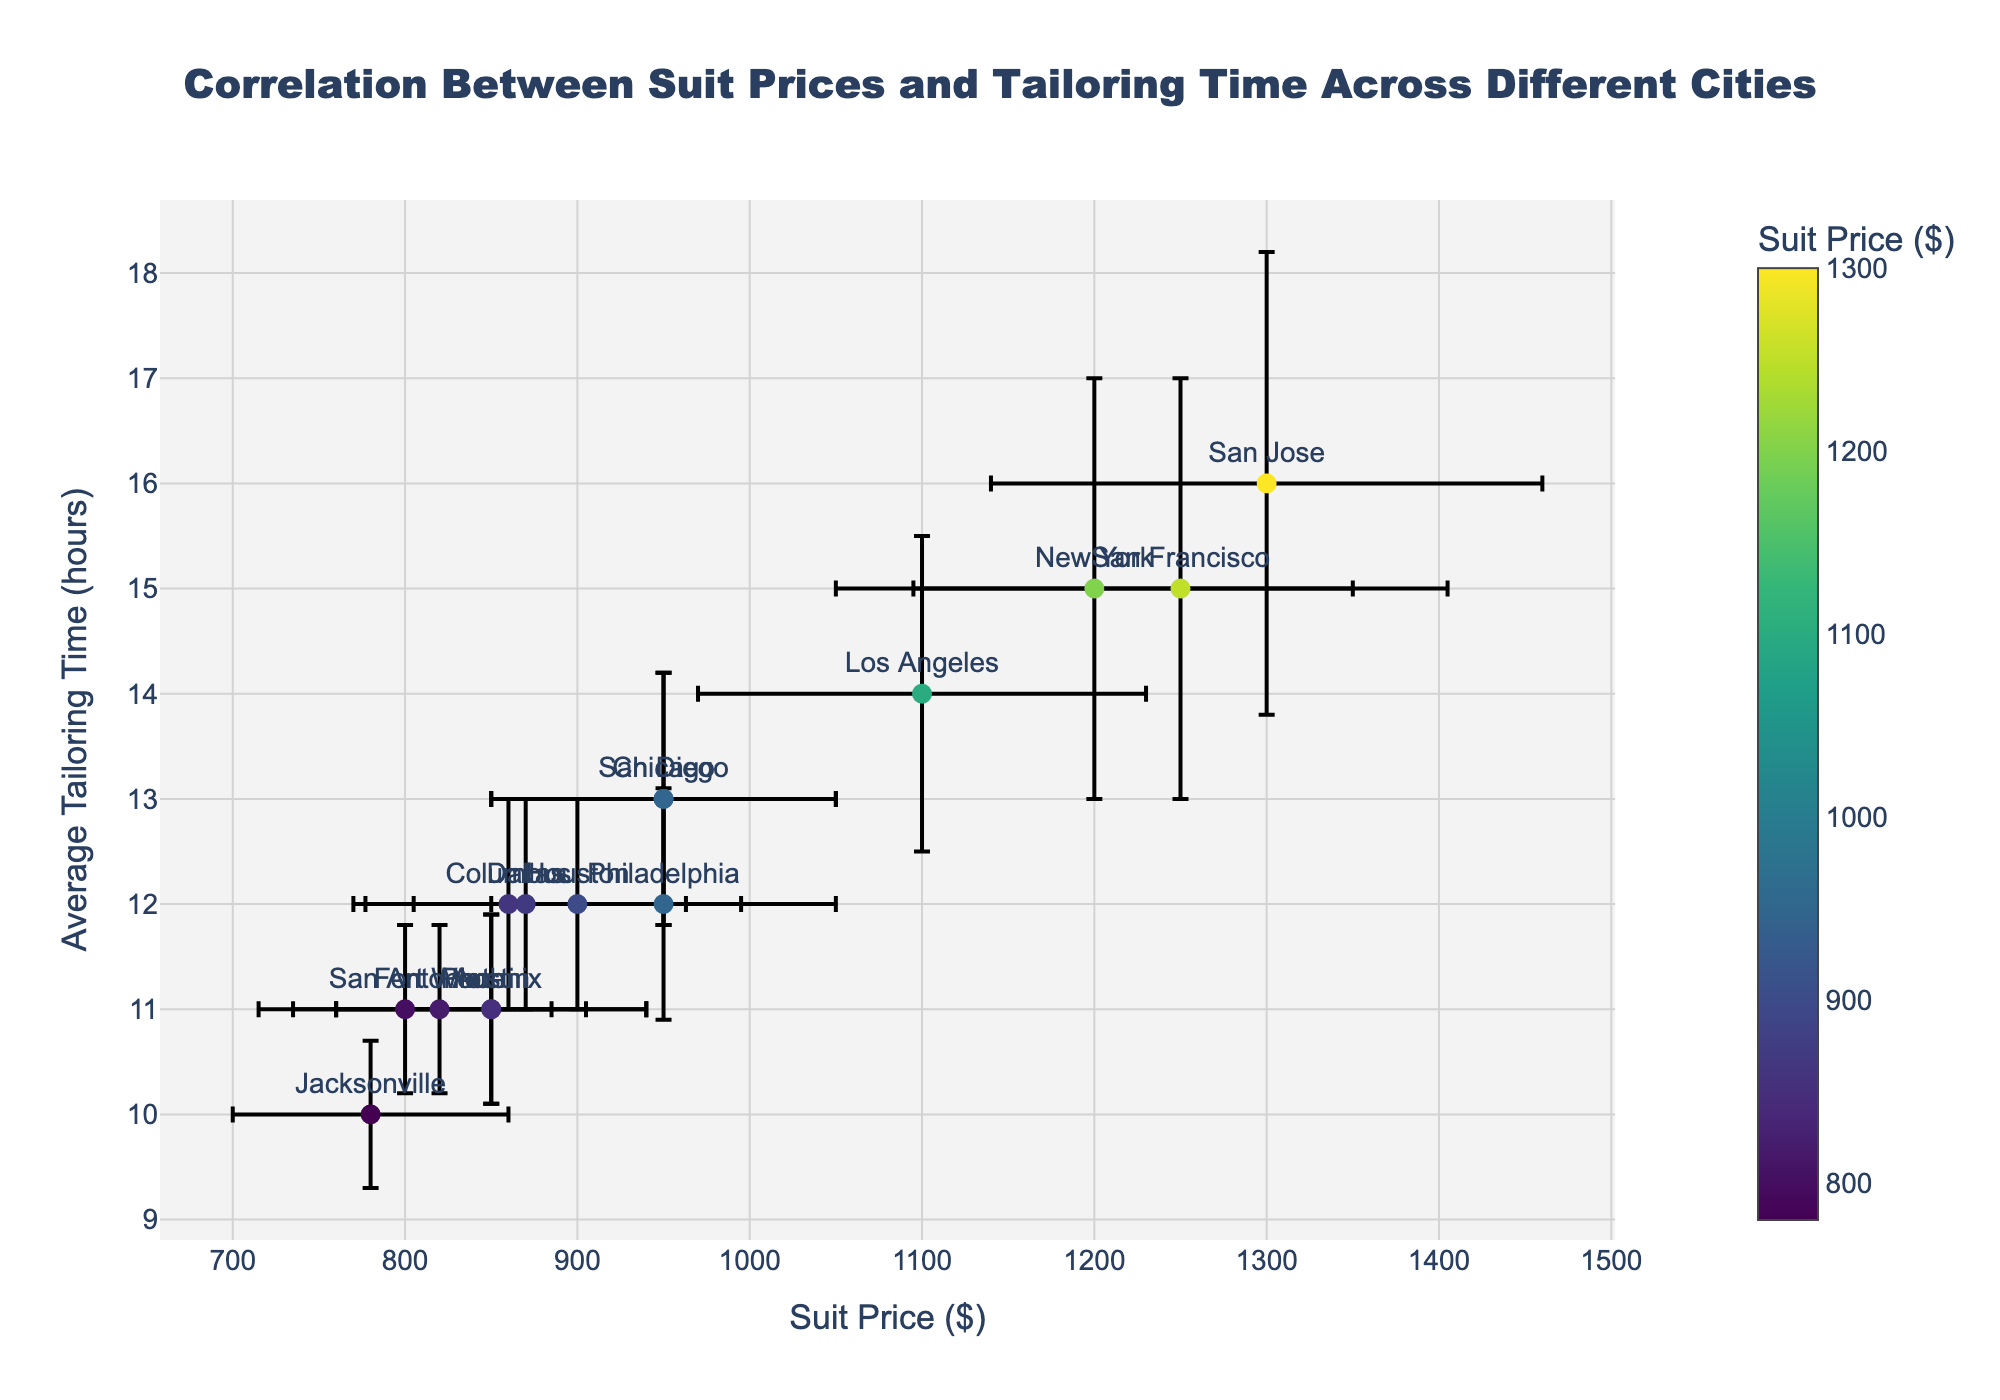What is the title of the plot? The title is located at the top center of the plot, it reads "Correlation Between Suit Prices and Tailoring Time Across Different Cities".
Answer: Correlation Between Suit Prices and Tailoring Time Across Different Cities What are the ranges of suit prices and average tailoring times displayed in the plot? The x-axis (suit prices) ranges from about $780 to $1300, and the y-axis (average tailoring times) ranges from about 10 to 16 hours.
Answer: $780 to $1300, 10 to 16 hours Which city has the highest suit price and what is its average tailoring time? The scatter point corresponding to San Jose has the highest suit price at $1300, with an average tailoring time of 16 hours.
Answer: San Jose, 16 hours What is the city with the lowest average tailoring time and its suit price? Jacksonville has the lowest average tailoring time of 10 hours, and its suit price is $780.
Answer: Jacksonville, $780 How many cities have an average tailoring time of 15 hours? Looking at the y-axis and the scatter points, two cities (New York and San Francisco) have an average tailoring time of 15 hours.
Answer: 2 Which city has a higher average tailoring time: Los Angeles or Chicago? From the plot, Los Angeles has an average tailoring time of 14 hours, while Chicago has 13 hours, so Los Angeles has a higher average tailoring time.
Answer: Los Angeles How do the error bars for suit price and tailoring time compare for New York and San Francisco? Both New York and San Francisco have similar length error bars for suit price (New York: $150, San Francisco: $155) and average tailoring time (both 2 hours), indicating comparable uncertainty in these measurements.
Answer: Comparable What is the average suit price among cities with an average tailoring time of 11 hours? The cities with an average tailoring time of 11 hours are Phoenix, San Antonio, Austin, and Fort Worth. Their suit prices are $850, $800, $850, and $820 respectively. The average suit price is calculated as ($850 + $800 + $850 + $820) / 4 = $830.
Answer: $830 Among the cities with an average tailoring time of 12 hours, which one has the lowest suit price? Houston and Columbus both have an average tailoring time of 12 hours. Houston's suit price is $900, Philadelphia $950, Dallas $870, and Columbus $860. The lowest suit price among these is from Columbus at $860.
Answer: Columbus, $860 Which city has both high suit price and high average tailoring time close to maximum values? San Jose stands out with the highest suit price ($1300) and the highest average tailoring time (16 hours).
Answer: San Jose 